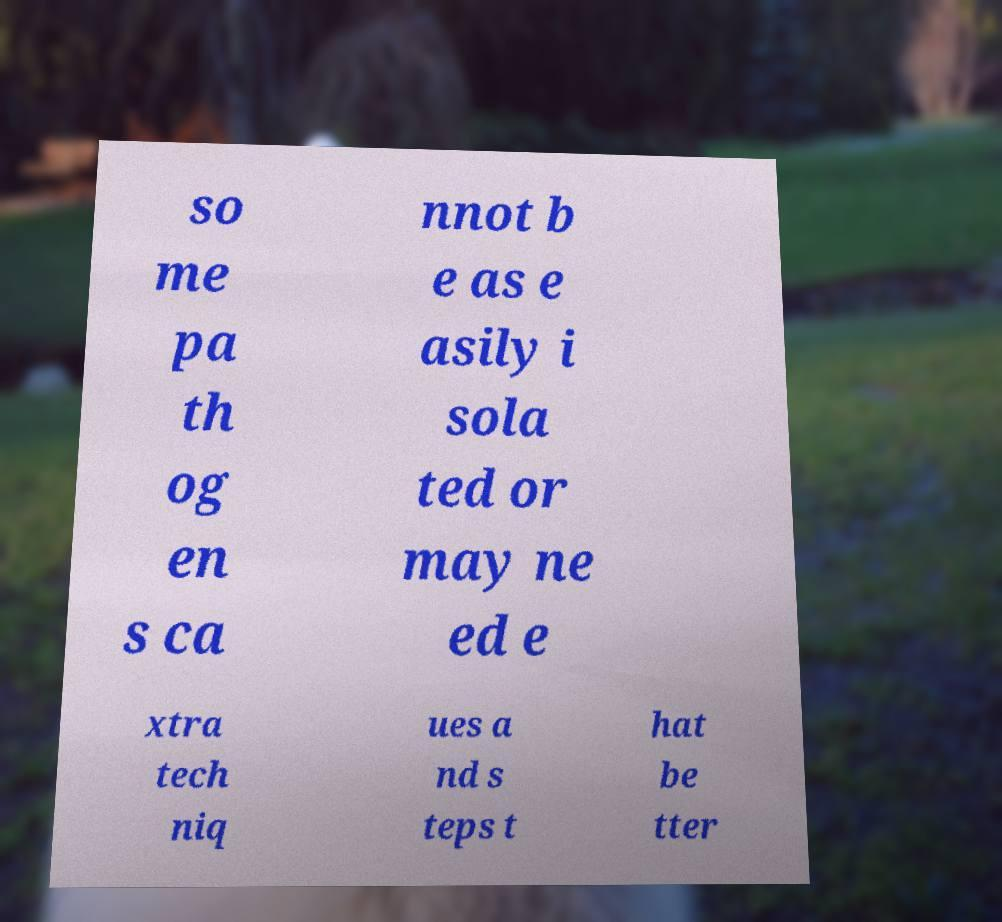Please identify and transcribe the text found in this image. so me pa th og en s ca nnot b e as e asily i sola ted or may ne ed e xtra tech niq ues a nd s teps t hat be tter 